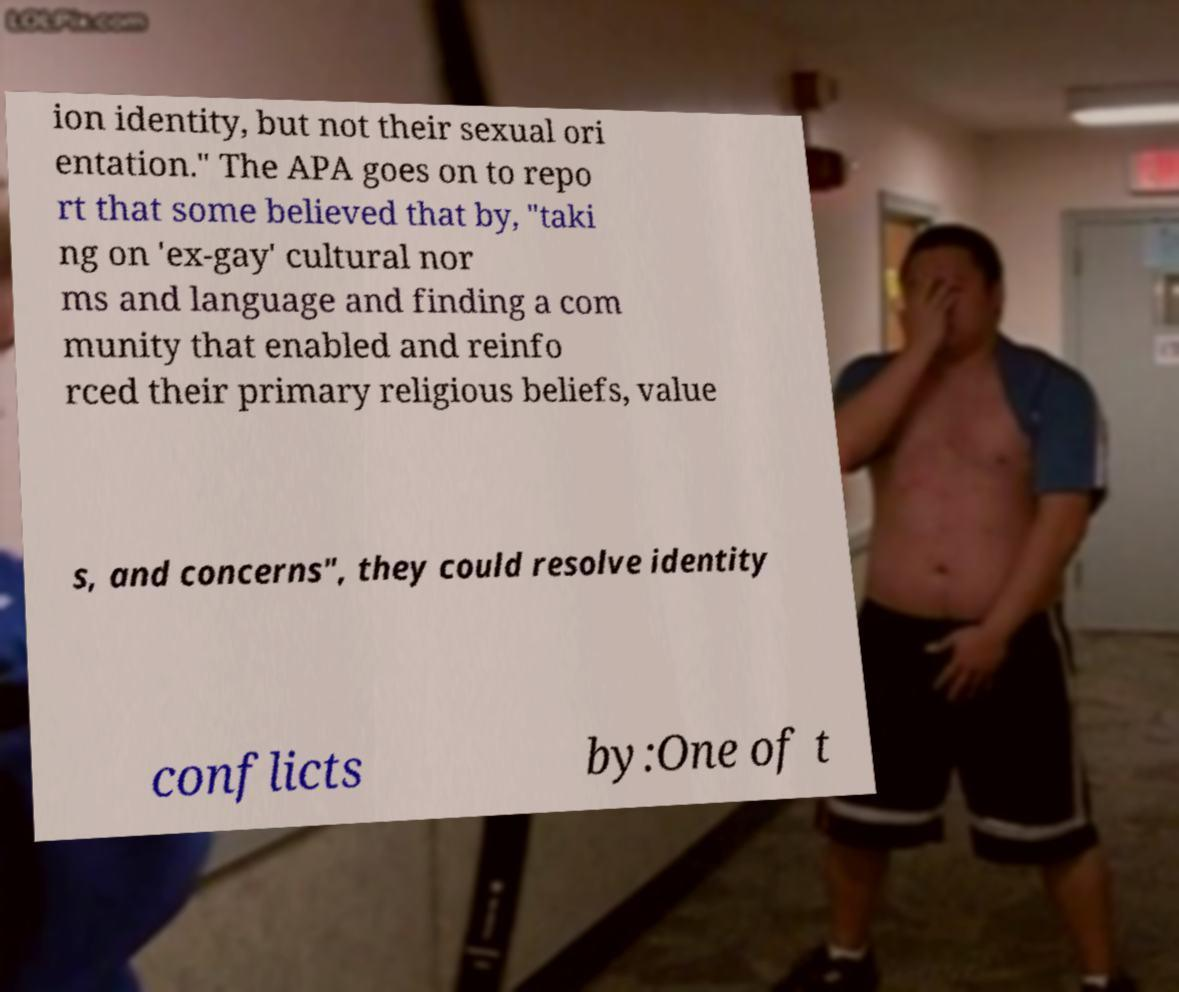I need the written content from this picture converted into text. Can you do that? ion identity, but not their sexual ori entation." The APA goes on to repo rt that some believed that by, "taki ng on 'ex-gay' cultural nor ms and language and finding a com munity that enabled and reinfo rced their primary religious beliefs, value s, and concerns", they could resolve identity conflicts by:One of t 